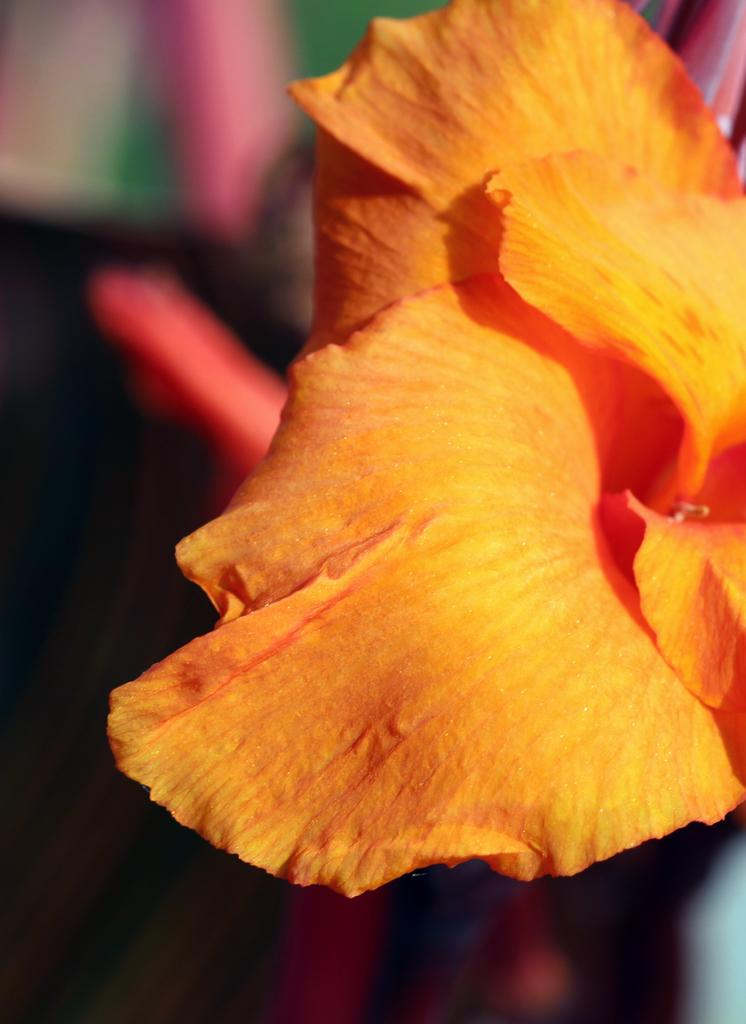What is the main subject of the image? There is a flower in the image. Can you describe the background of the image? The background of the image is blurry. What type of wine is being poured into the glass in the image? There is no glass or wine present in the image; it features a flower with a blurry background. How does the flower attract attention in the image? The flower is the main subject of the image, so it naturally attracts attention by being the focus of the image. 